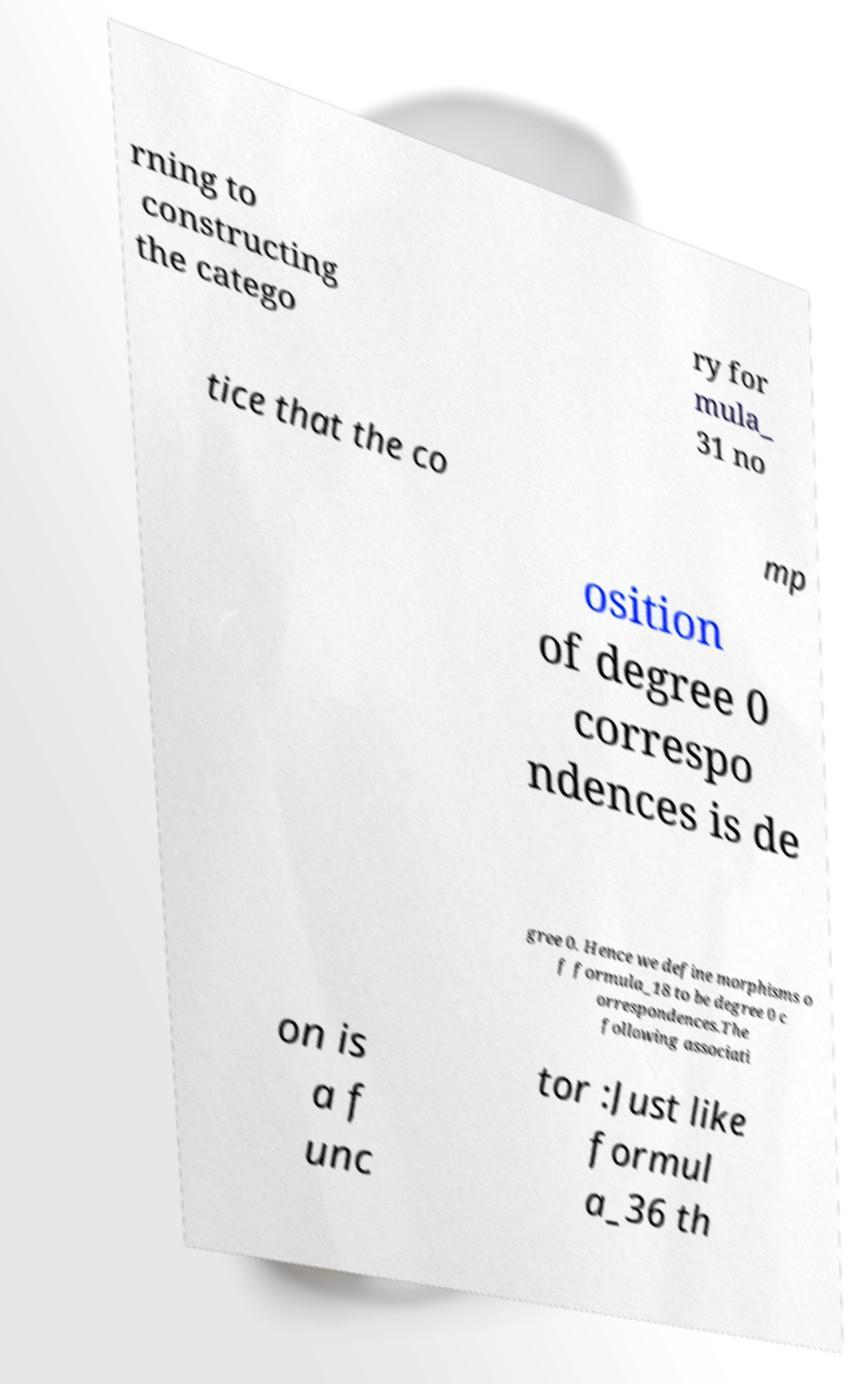Could you assist in decoding the text presented in this image and type it out clearly? rning to constructing the catego ry for mula_ 31 no tice that the co mp osition of degree 0 correspo ndences is de gree 0. Hence we define morphisms o f formula_18 to be degree 0 c orrespondences.The following associati on is a f unc tor :Just like formul a_36 th 